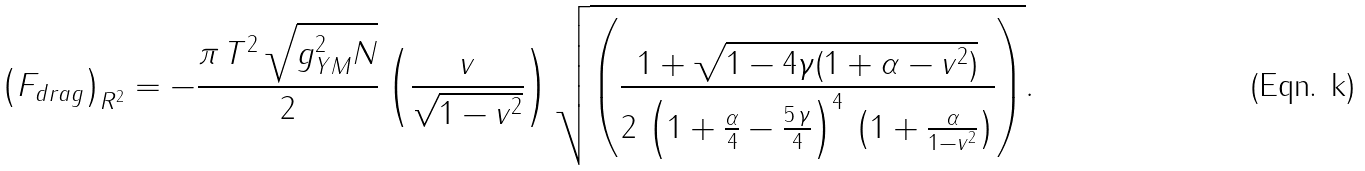<formula> <loc_0><loc_0><loc_500><loc_500>\left ( F _ { d r a g } \right ) _ { R ^ { 2 } } = - \frac { \pi \, T ^ { 2 } \, \sqrt { g _ { Y M } ^ { 2 } N } } { 2 } \left ( \frac { v } { \sqrt { 1 - v ^ { 2 } } } \right ) \sqrt { \left ( \frac { 1 + \sqrt { 1 - 4 \gamma ( 1 + \alpha - v ^ { 2 } ) } } { 2 \, \left ( 1 + \frac { \alpha } { 4 } - \frac { 5 \, \gamma } { 4 } \right ) ^ { 4 } \, \left ( 1 + \frac { \alpha } { 1 - v ^ { 2 } } \right ) } \right ) } .</formula> 